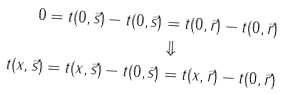<formula> <loc_0><loc_0><loc_500><loc_500>0 = t ( 0 , \vec { s } ) - t ( 0 , \vec { s } ) & = t ( 0 , \vec { r } ) - t ( 0 , \vec { r } ) \\ & \Downarrow \\ t ( x , \vec { s } ) = t ( x , \vec { s } ) - t ( 0 , \vec { s } ) & = t ( x , \vec { r } ) - t ( 0 , \vec { r } )</formula> 